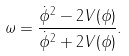<formula> <loc_0><loc_0><loc_500><loc_500>\omega = \frac { { \dot { \phi } } ^ { 2 } - 2 V ( \phi ) } { { \dot { \phi } } ^ { 2 } + 2 V ( \phi ) } .</formula> 